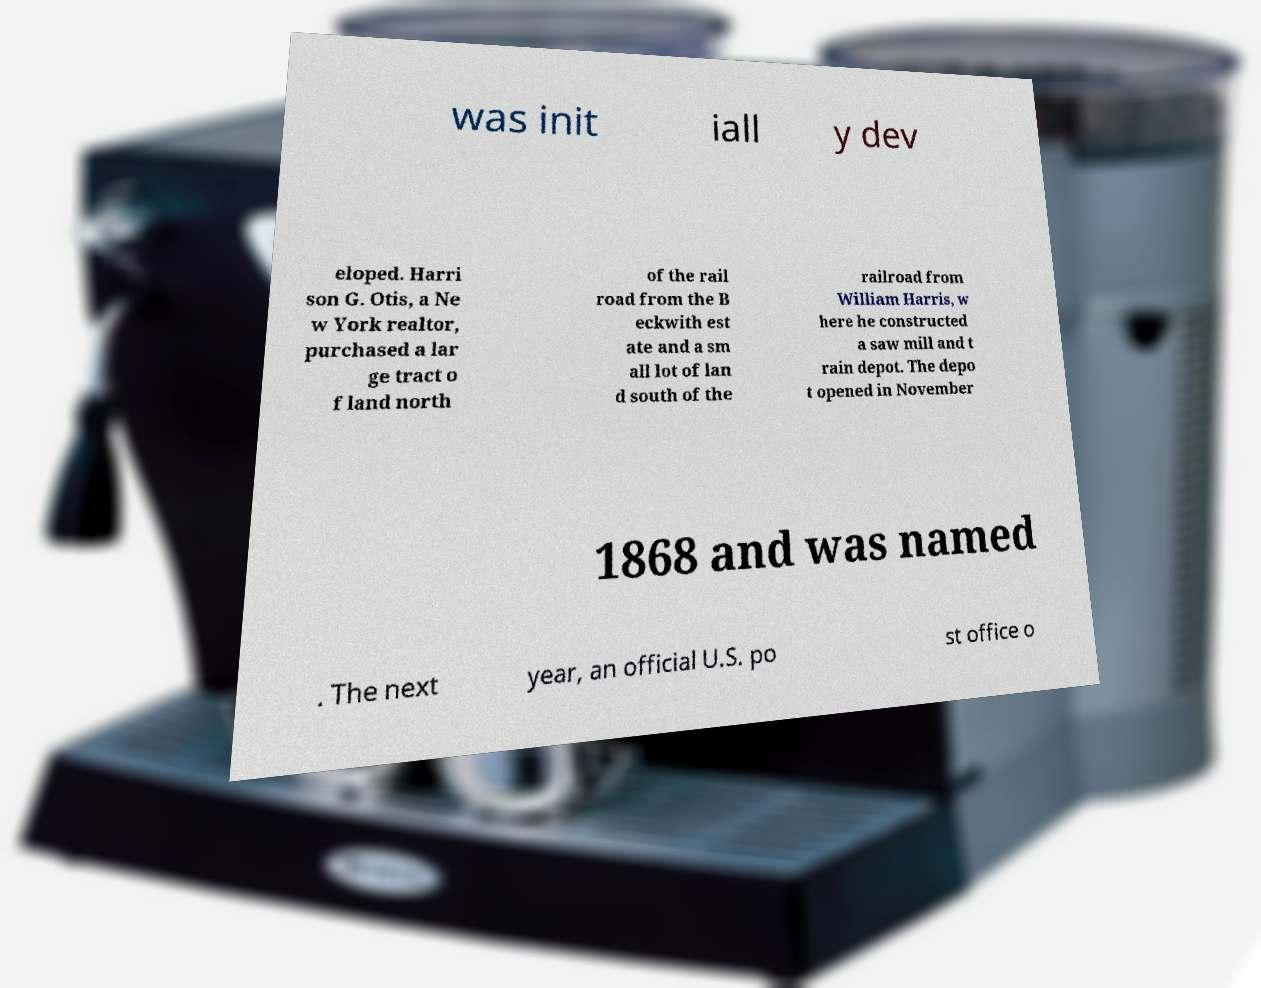Can you read and provide the text displayed in the image?This photo seems to have some interesting text. Can you extract and type it out for me? was init iall y dev eloped. Harri son G. Otis, a Ne w York realtor, purchased a lar ge tract o f land north of the rail road from the B eckwith est ate and a sm all lot of lan d south of the railroad from William Harris, w here he constructed a saw mill and t rain depot. The depo t opened in November 1868 and was named . The next year, an official U.S. po st office o 